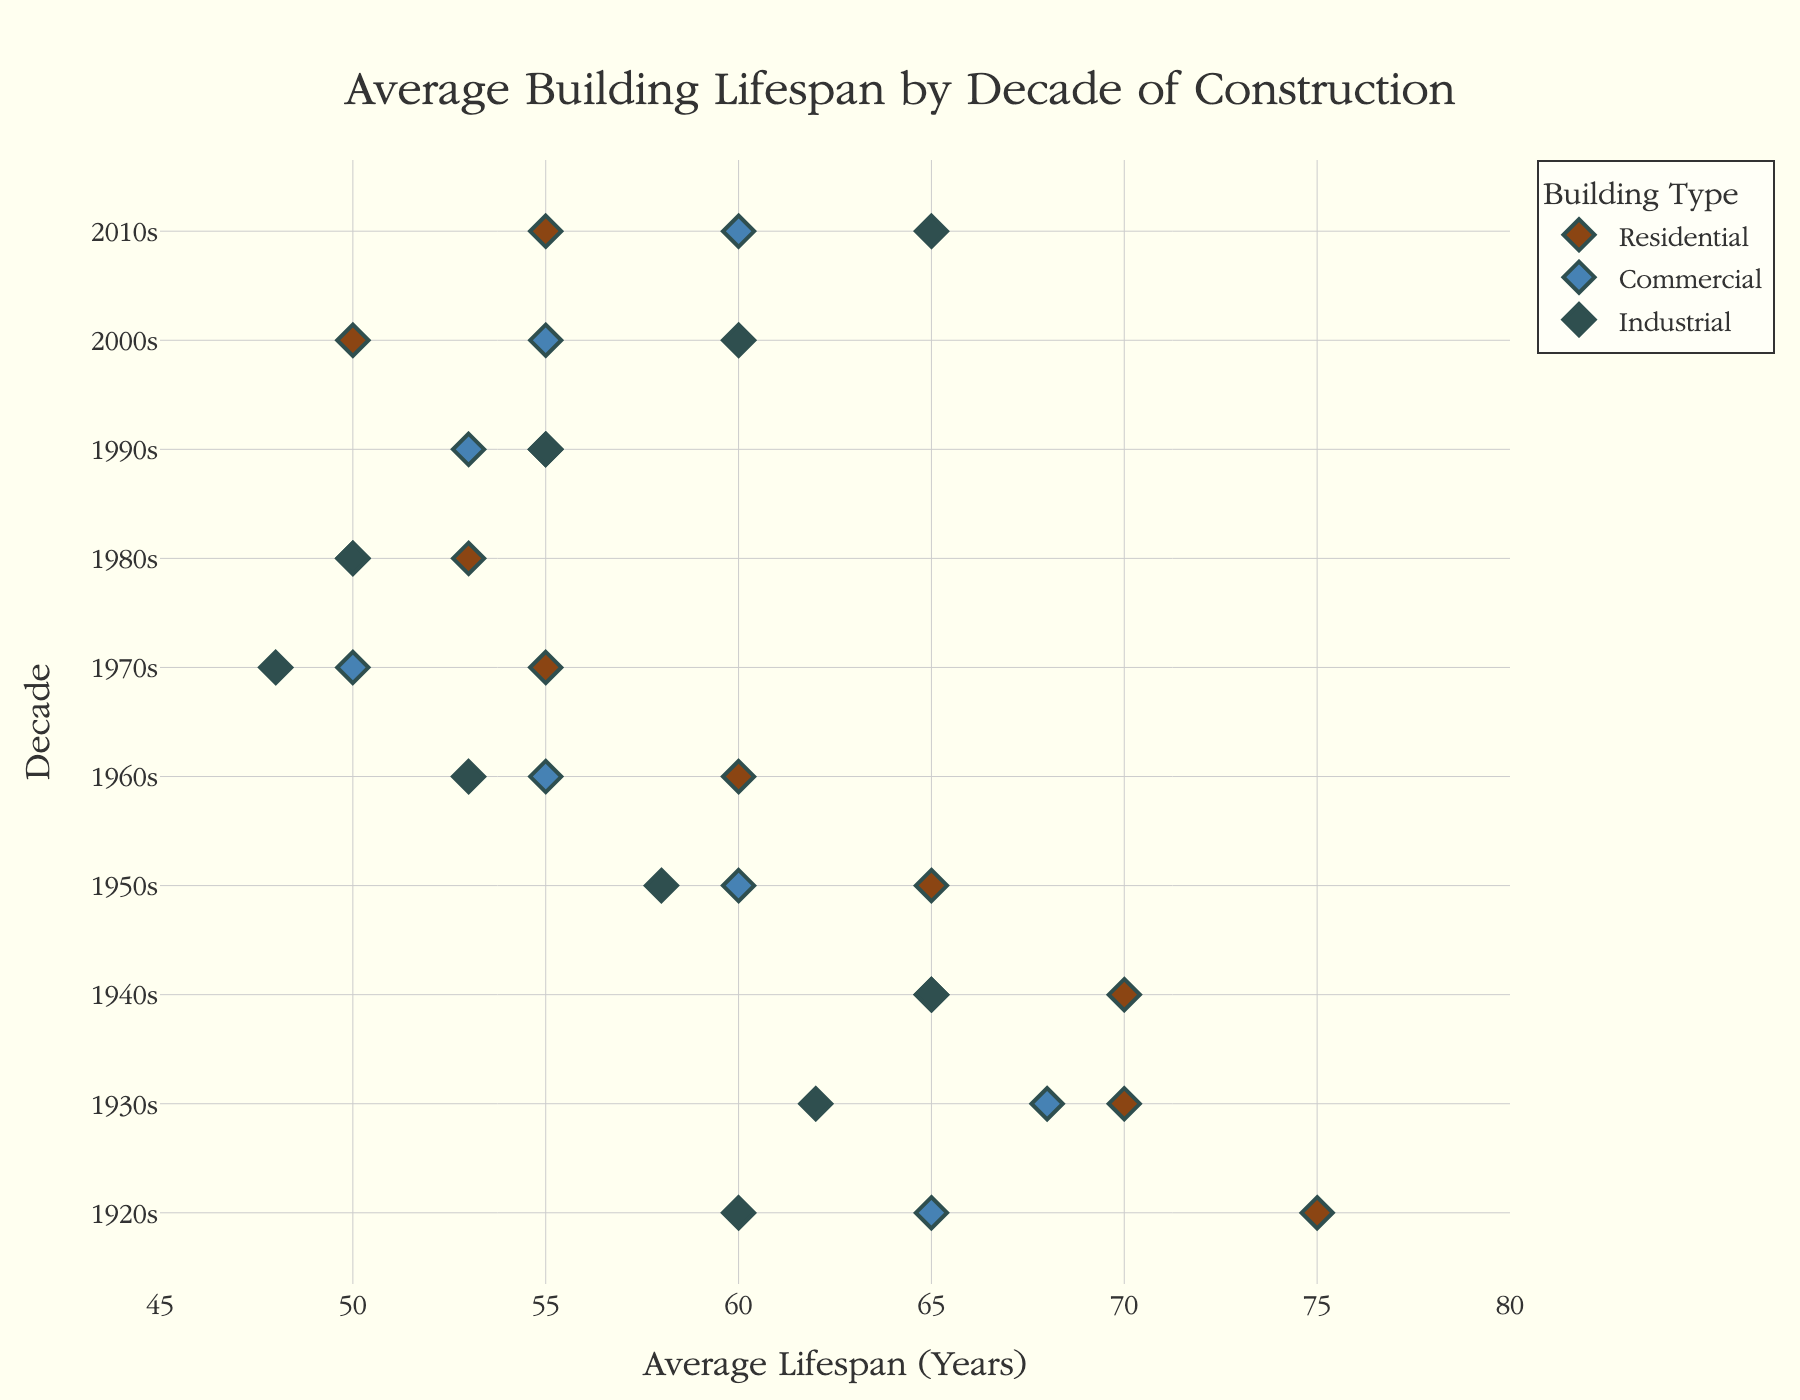What is the title of the figure? The visual title of the figure, located at the top, is "Average Building Lifespan by Decade of Construction." This can be seen directly in the plot.
Answer: Average Building Lifespan by Decade of Construction Which decade has the highest average lifespan for industrial buildings? Inspect the y-axis for the "Industrial" category and the x-axis values. The 1920s' industrial buildings have the highest average lifespan at 60 years.
Answer: 1920s How does the average lifespan for residential buildings in the 1940s compare to those in the 1960s? From the dot plot, the average lifespan of residential buildings in the 1940s is 70 years, whereas it is 60 years in the 1960s. The 1940s residential buildings last 10 years longer.
Answer: 70 years vs. 60 years; 1940s buildings last 10 years longer What is the difference in average lifespan between commercial buildings of the 1970s and the 2000s? The average lifespan of commercial buildings in the 1970s is 50 years, and in the 2000s, it is 55 years. The difference is 55 - 50 = 5 years.
Answer: 5 years Which building type shows a consistent increase in lifespan from the 1960s to the 2010s? Inspect the markers along the x-axis for each building type across the decades. The "Industrial" category shows an increase from 53 years in the 1960s to 65 years in the 2010s.
Answer: Industrial What is the average lifespan range for residential buildings across all decades? Look at the x-axis points for "Residential" across all decades. They range from the lowest at 50 years (2000s) to the highest at 75 years (1920s). The range is 75 - 50 = 25 years.
Answer: 25 years How do the average lifespans of commercial buildings in the 1990s compare to the 2010s? From the plot, the average lifespan for commercial buildings in the 1990s is 53 years and that in the 2010s is 60 years. Buildings in the 2010s last 7 years longer.
Answer: 7 years longer Which decade marks the lowest average lifespan for industrial buildings? On analyzing the industrial data points, the 1970s mark the lowest at 48 years.
Answer: 1970s What trend is observed in the average lifespan of residential buildings from the 1920s to the 1980s? The residential building lifespan generally declines. Starting from 75 years in the 1920s and gradually decreasing to 53 years in the 1980s.
Answer: Declining trend Which decade saw the greatest variability in average lifespan among different building types? Compare and measure the range of average lifespan among all building types in each decade. The 2010s have the greatest variability, ranging from 55 to 65 years (range of 10 years).
Answer: 2010s 